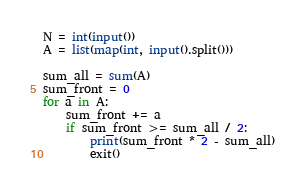<code> <loc_0><loc_0><loc_500><loc_500><_Python_>N = int(input())
A = list(map(int, input().split()))

sum_all = sum(A)
sum_front = 0
for a in A:
    sum_front += a
    if sum_front >= sum_all / 2:
        print(sum_front * 2 - sum_all)
        exit()
</code> 